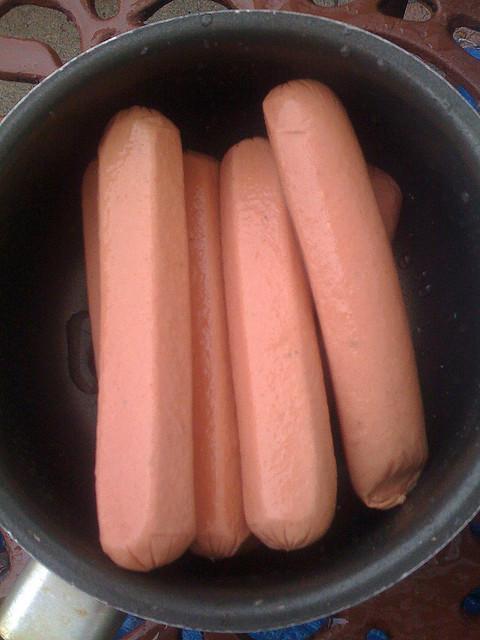What is bad about this food?
Answer the question by selecting the correct answer among the 4 following choices and explain your choice with a short sentence. The answer should be formatted with the following format: `Answer: choice
Rationale: rationale.`
Options: High fat, high carb, high sugar, high sodium. Answer: high sodium.
Rationale: The hot dogs have sodium. 